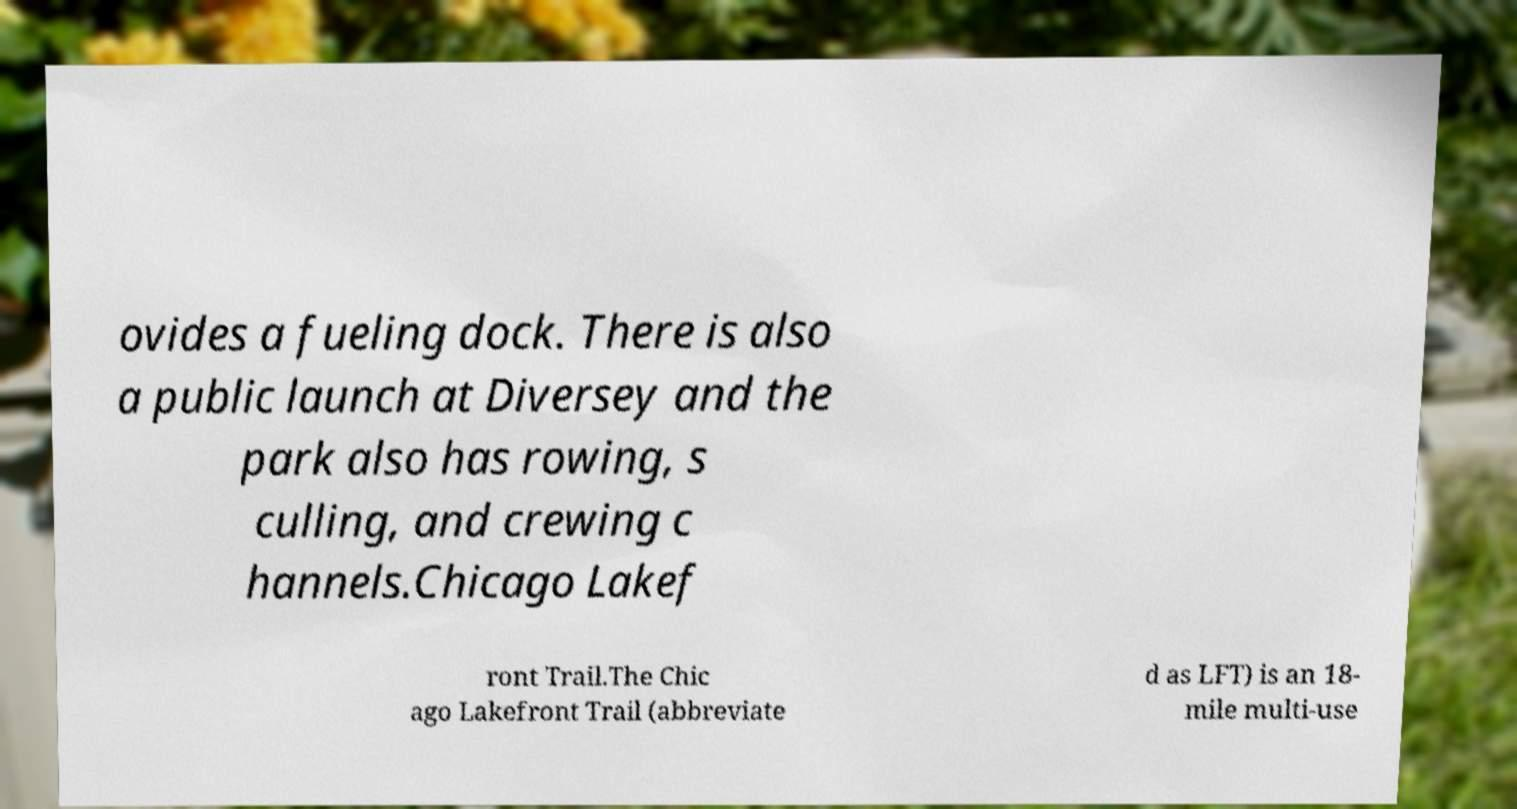What messages or text are displayed in this image? I need them in a readable, typed format. ovides a fueling dock. There is also a public launch at Diversey and the park also has rowing, s culling, and crewing c hannels.Chicago Lakef ront Trail.The Chic ago Lakefront Trail (abbreviate d as LFT) is an 18- mile multi-use 